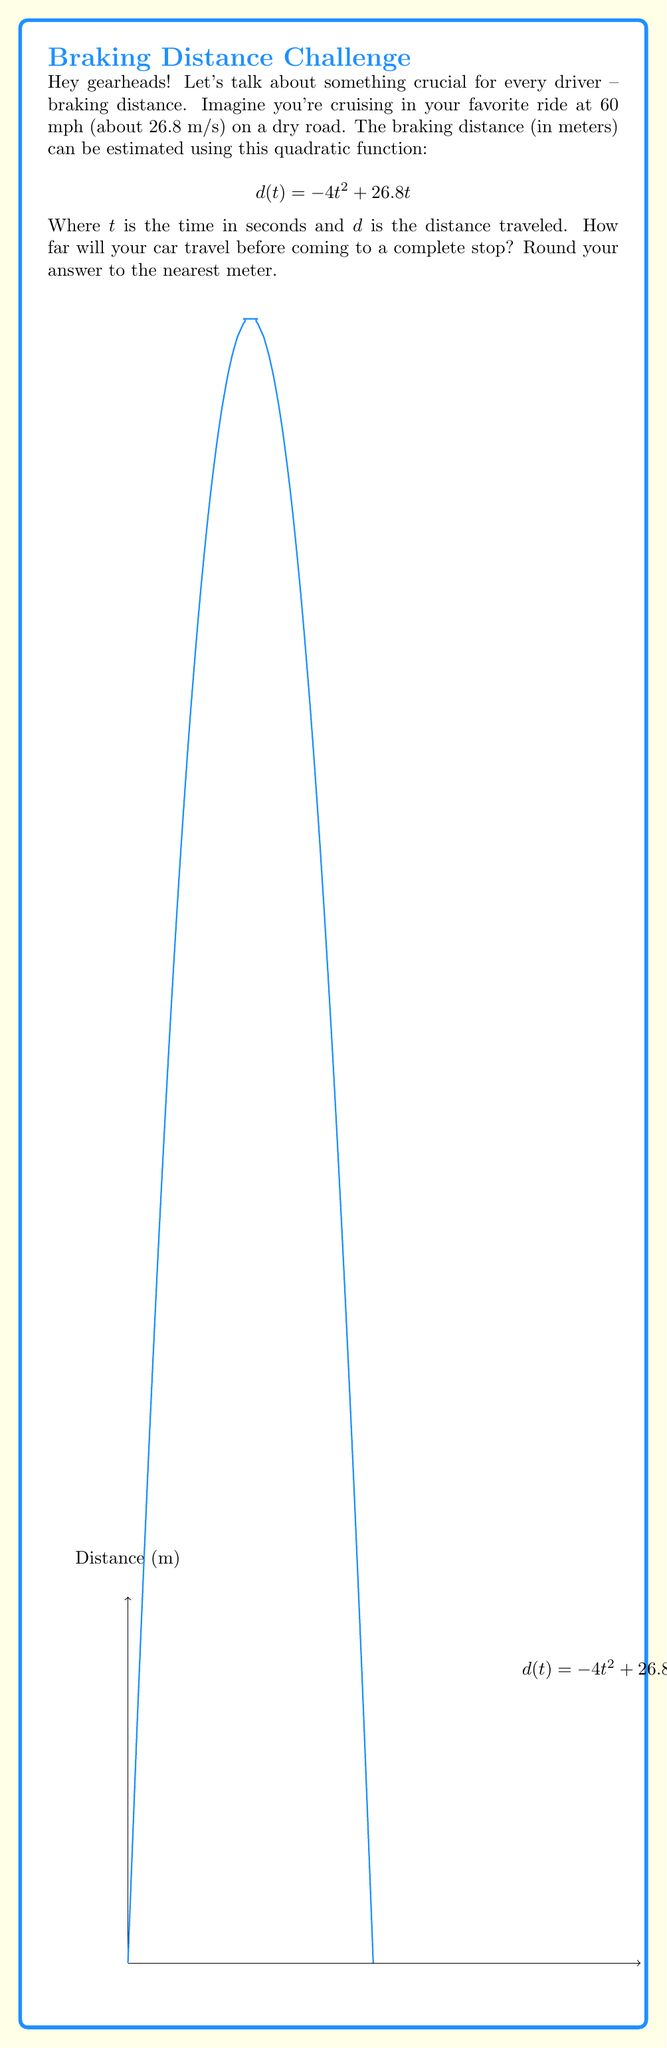What is the answer to this math problem? Alright, let's break this down step-by-step:

1) First, we need to find when the car comes to a complete stop. This happens when the distance function reaches its maximum value. 

2) To find the maximum, we need to find where the derivative of $d(t)$ equals zero:

   $\frac{d}{dt}d(t) = -8t + 26.8$
   
   Set this to zero:
   $-8t + 26.8 = 0$
   $-8t = -26.8$
   $t = 3.35$ seconds

3) Now that we know the time it takes to stop, we can plug this back into our original function to find the distance:

   $d(3.35) = -4(3.35)^2 + 26.8(3.35)$
   
4) Let's calculate this step-by-step:
   $= -4(11.2225) + 89.78$
   $= -44.89 + 89.78$
   $= 44.89$ meters

5) Rounding to the nearest meter, we get 45 meters.

This means your car will travel about 45 meters (or roughly 148 feet) before coming to a complete stop from 60 mph on a dry road. Remember, this is just an estimate – always leave plenty of stopping distance in real-world driving!
Answer: 45 meters 